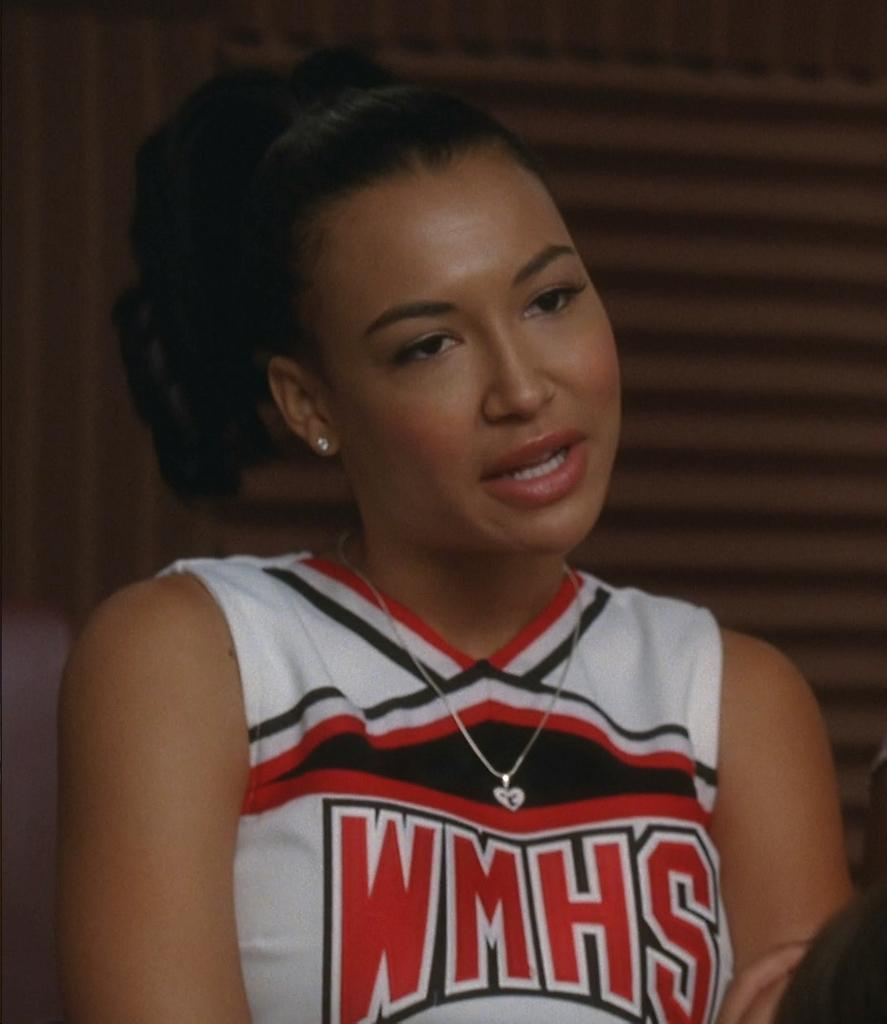<image>
Describe the image concisely. A woman wearing a WMHS jersey has her mouth open and her head is tilted. 